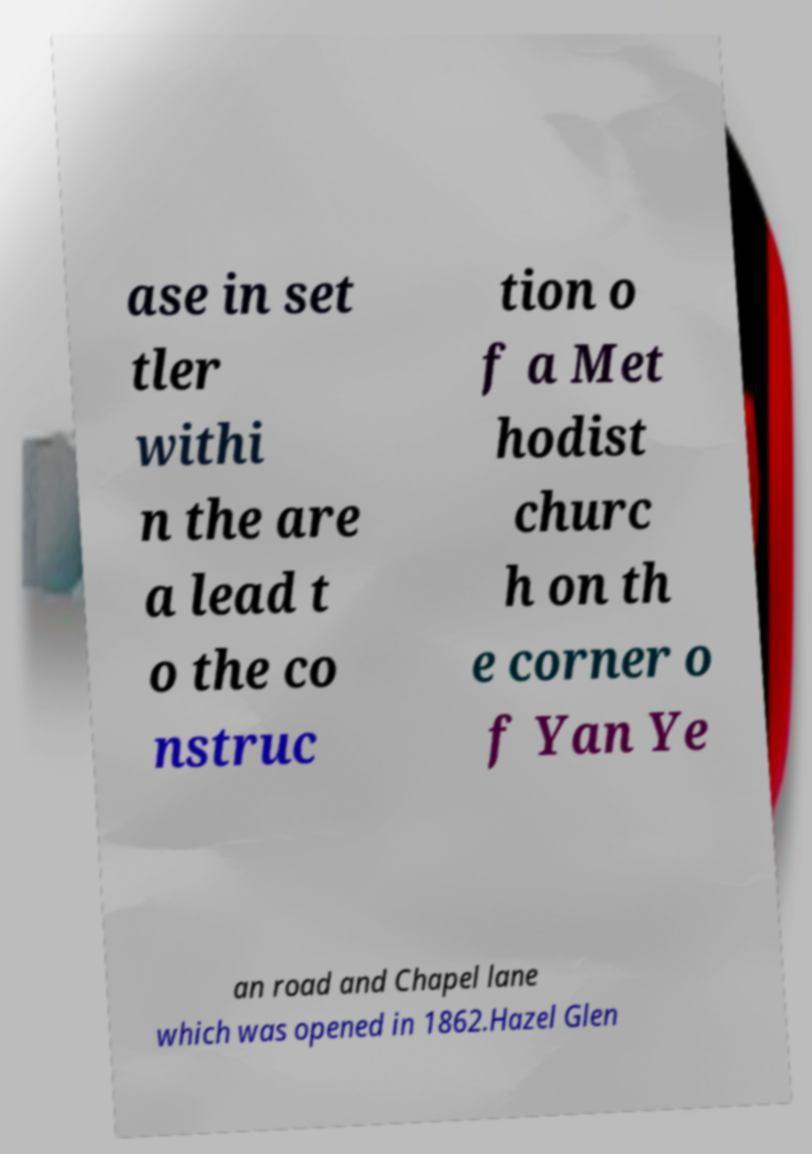Could you extract and type out the text from this image? ase in set tler withi n the are a lead t o the co nstruc tion o f a Met hodist churc h on th e corner o f Yan Ye an road and Chapel lane which was opened in 1862.Hazel Glen 